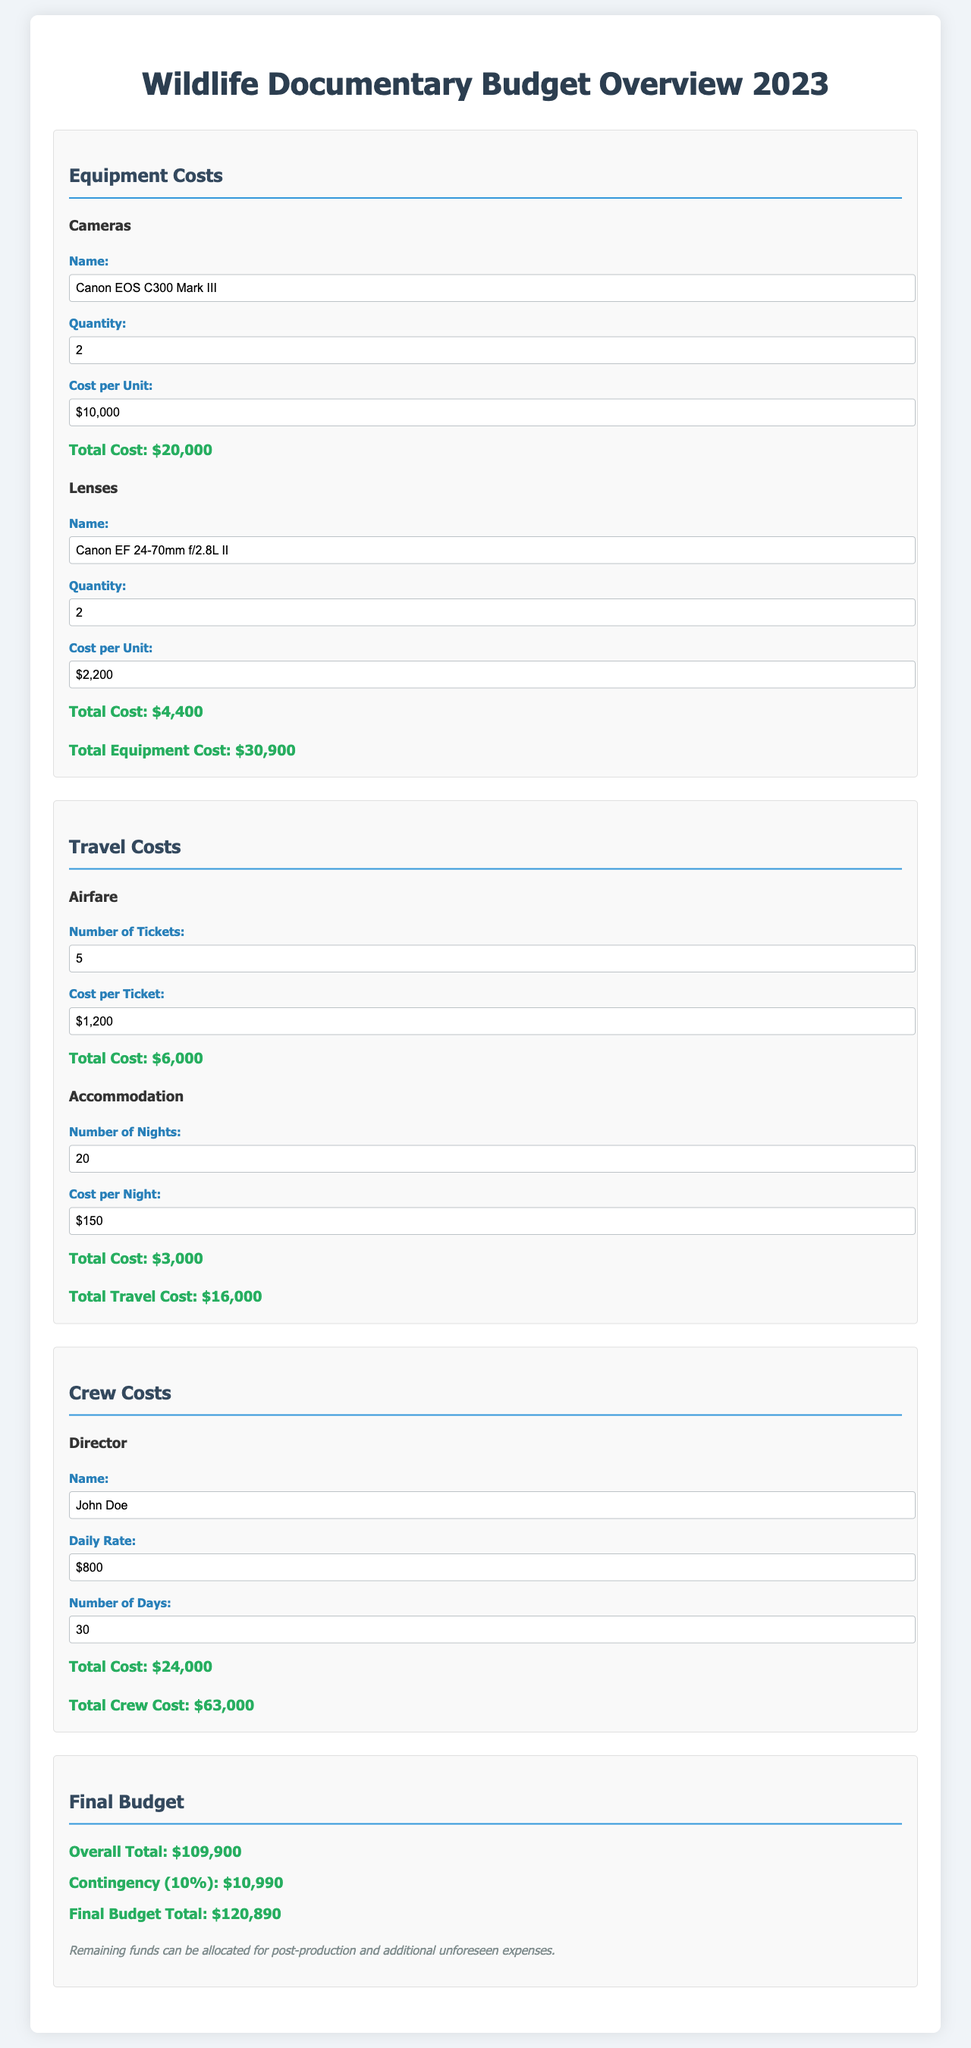What is the total equipment cost? The total equipment cost can be found in the equipment section of the document, which sums the costs of cameras and lenses, amounting to $30,900.
Answer: $30,900 How many cameras are included in the budget? The budget specifies that there are 2 cameras listed under equipment costs.
Answer: 2 What is the daily rate for the director? The document specifies the daily rate for the director as $800 in the crew costs section.
Answer: $800 What is the total travel cost? The travel costs total, including airfare and accommodation, is provided in the travel section, which amounts to $16,000.
Answer: $16,000 How long is the crew expected to stay for accommodation? The document indicates that the crew is expected to stay for 20 nights as noted in the accommodation sub-section.
Answer: 20 What is the overall total of the budget before contingency? The overall total is mentioned in the final budget section before any contingency is added, which is $109,900.
Answer: $109,900 How much is the contingency amount? The contingency amount is specified as 10% of the overall total, which is listed as $10,990.
Answer: $10,990 What is the final budget total? The final budget total, including the overall total and contingency, is stated as $120,890 in the document.
Answer: $120,890 What is the cost per ticket for airfare? The document lists the cost per ticket for airfare as $1,200 in the travel costs section.
Answer: $1,200 